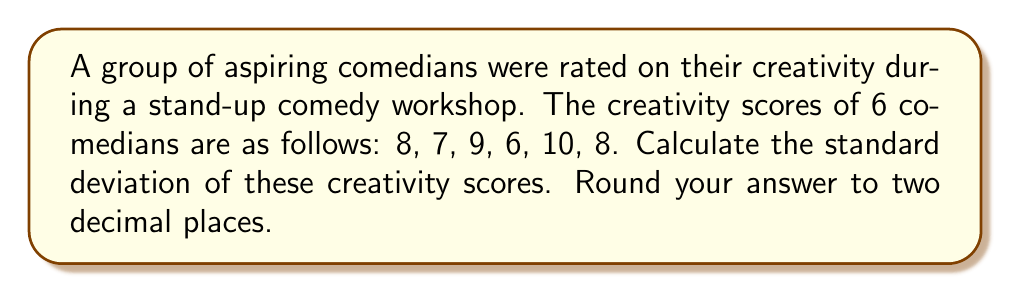Show me your answer to this math problem. To calculate the standard deviation, we'll follow these steps:

1. Calculate the mean ($\mu$) of the scores:
   $$\mu = \frac{8 + 7 + 9 + 6 + 10 + 8}{6} = 8$$

2. Calculate the squared differences from the mean:
   $$(8 - 8)^2 = 0$$
   $$(7 - 8)^2 = 1$$
   $$(9 - 8)^2 = 1$$
   $$(6 - 8)^2 = 4$$
   $$(10 - 8)^2 = 4$$
   $$(8 - 8)^2 = 0$$

3. Sum the squared differences:
   $$0 + 1 + 1 + 4 + 4 + 0 = 10$$

4. Divide the sum by $(n-1)$, where $n$ is the number of scores:
   $$\frac{10}{6-1} = \frac{10}{5} = 2$$

5. Take the square root of this value to get the standard deviation:
   $$\sigma = \sqrt{2} \approx 1.41$$

Therefore, the standard deviation of the creativity scores is approximately 1.41.
Answer: 1.41 